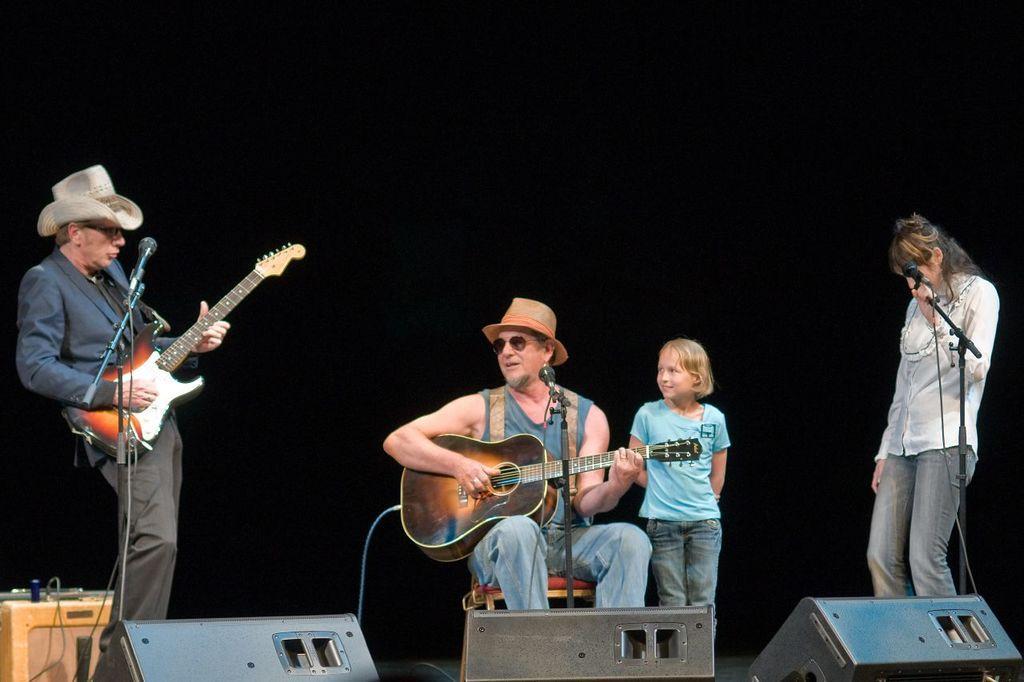Please provide a concise description of this image. This image is clicked in a musical concert. There are four people one is standing on the left side. The other one is standing on the right side. In the middle there is a man sitting on chair. They are playing guitars. There is a kid in the middle. The one who is on the right side is holding a mic the one who is on the left side is playing guitar and mic is in front of him. 